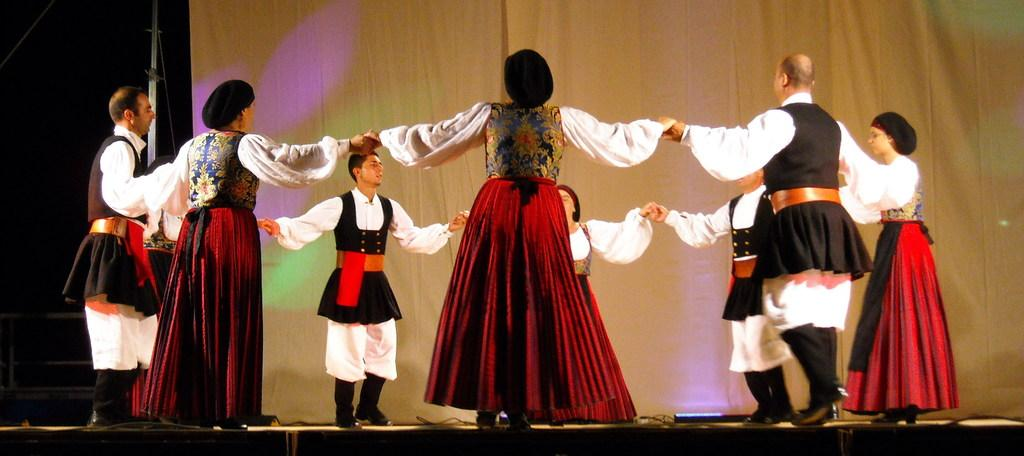What types of people are in the image? There are men and women in the image. What are the men and women doing in the image? The men and women are standing and holding hands. What type of drink is being served at the art exhibit in the image? There is no art exhibit or drink present in the image; it only shows men and women standing and holding hands. 